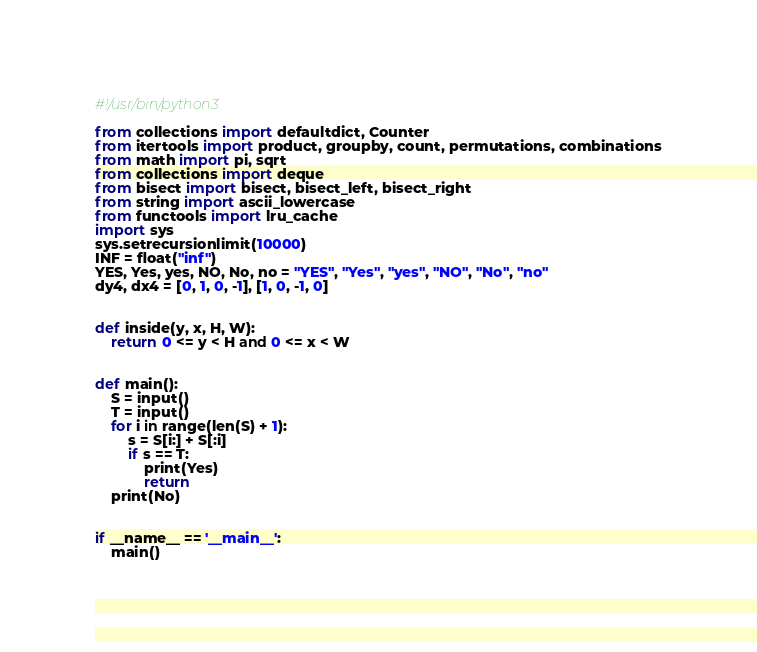<code> <loc_0><loc_0><loc_500><loc_500><_Python_>#!/usr/bin/python3

from collections import defaultdict, Counter
from itertools import product, groupby, count, permutations, combinations
from math import pi, sqrt
from collections import deque
from bisect import bisect, bisect_left, bisect_right
from string import ascii_lowercase
from functools import lru_cache
import sys
sys.setrecursionlimit(10000)
INF = float("inf")
YES, Yes, yes, NO, No, no = "YES", "Yes", "yes", "NO", "No", "no"
dy4, dx4 = [0, 1, 0, -1], [1, 0, -1, 0]


def inside(y, x, H, W):
    return 0 <= y < H and 0 <= x < W


def main():
    S = input()
    T = input()
    for i in range(len(S) + 1):
        s = S[i:] + S[:i]
        if s == T:
            print(Yes)
            return
    print(No)


if __name__ == '__main__':
    main()
</code> 